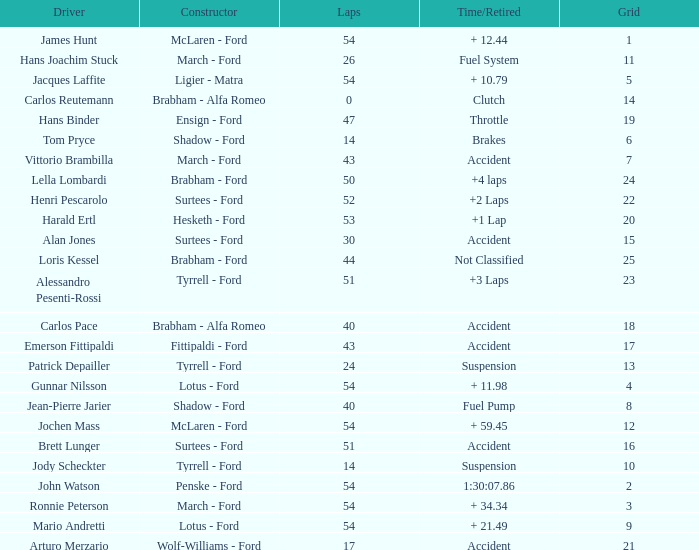What is the Time/Retired of Carlos Reutemann who was driving a brabham - Alfa Romeo? Clutch. 